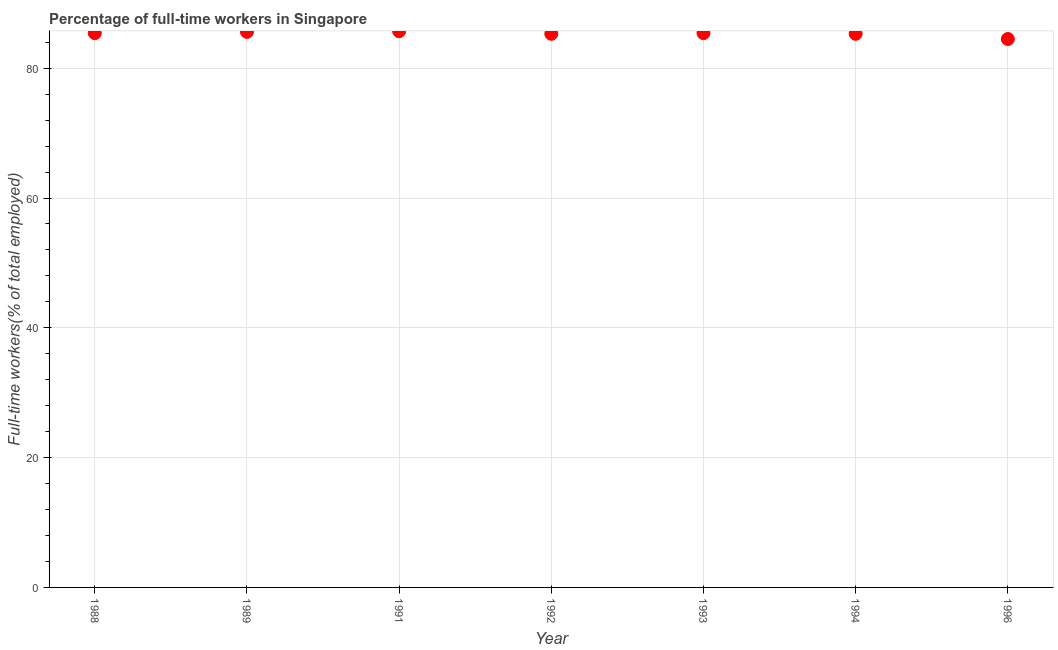What is the percentage of full-time workers in 1988?
Your response must be concise. 85.4. Across all years, what is the maximum percentage of full-time workers?
Make the answer very short. 85.7. Across all years, what is the minimum percentage of full-time workers?
Ensure brevity in your answer.  84.5. In which year was the percentage of full-time workers minimum?
Offer a terse response. 1996. What is the sum of the percentage of full-time workers?
Your answer should be very brief. 597.2. What is the difference between the percentage of full-time workers in 1994 and 1996?
Offer a very short reply. 0.8. What is the average percentage of full-time workers per year?
Your answer should be very brief. 85.31. What is the median percentage of full-time workers?
Your answer should be compact. 85.4. In how many years, is the percentage of full-time workers greater than 40 %?
Provide a short and direct response. 7. What is the ratio of the percentage of full-time workers in 1989 to that in 1992?
Provide a short and direct response. 1. Is the difference between the percentage of full-time workers in 1993 and 1994 greater than the difference between any two years?
Provide a succinct answer. No. What is the difference between the highest and the second highest percentage of full-time workers?
Provide a succinct answer. 0.1. What is the difference between the highest and the lowest percentage of full-time workers?
Provide a short and direct response. 1.2. Does the percentage of full-time workers monotonically increase over the years?
Provide a succinct answer. No. How many dotlines are there?
Your response must be concise. 1. How many years are there in the graph?
Keep it short and to the point. 7. What is the difference between two consecutive major ticks on the Y-axis?
Ensure brevity in your answer.  20. Does the graph contain grids?
Keep it short and to the point. Yes. What is the title of the graph?
Offer a very short reply. Percentage of full-time workers in Singapore. What is the label or title of the X-axis?
Your answer should be very brief. Year. What is the label or title of the Y-axis?
Make the answer very short. Full-time workers(% of total employed). What is the Full-time workers(% of total employed) in 1988?
Your answer should be compact. 85.4. What is the Full-time workers(% of total employed) in 1989?
Your answer should be compact. 85.6. What is the Full-time workers(% of total employed) in 1991?
Your response must be concise. 85.7. What is the Full-time workers(% of total employed) in 1992?
Give a very brief answer. 85.3. What is the Full-time workers(% of total employed) in 1993?
Give a very brief answer. 85.4. What is the Full-time workers(% of total employed) in 1994?
Ensure brevity in your answer.  85.3. What is the Full-time workers(% of total employed) in 1996?
Ensure brevity in your answer.  84.5. What is the difference between the Full-time workers(% of total employed) in 1988 and 1989?
Your answer should be very brief. -0.2. What is the difference between the Full-time workers(% of total employed) in 1988 and 1991?
Provide a succinct answer. -0.3. What is the difference between the Full-time workers(% of total employed) in 1988 and 1992?
Offer a very short reply. 0.1. What is the difference between the Full-time workers(% of total employed) in 1988 and 1993?
Your response must be concise. 0. What is the difference between the Full-time workers(% of total employed) in 1988 and 1994?
Your answer should be very brief. 0.1. What is the difference between the Full-time workers(% of total employed) in 1989 and 1991?
Make the answer very short. -0.1. What is the difference between the Full-time workers(% of total employed) in 1989 and 1993?
Give a very brief answer. 0.2. What is the difference between the Full-time workers(% of total employed) in 1989 and 1996?
Offer a terse response. 1.1. What is the difference between the Full-time workers(% of total employed) in 1991 and 1992?
Ensure brevity in your answer.  0.4. What is the difference between the Full-time workers(% of total employed) in 1991 and 1993?
Offer a terse response. 0.3. What is the difference between the Full-time workers(% of total employed) in 1991 and 1994?
Make the answer very short. 0.4. What is the difference between the Full-time workers(% of total employed) in 1991 and 1996?
Offer a very short reply. 1.2. What is the difference between the Full-time workers(% of total employed) in 1993 and 1994?
Offer a very short reply. 0.1. What is the difference between the Full-time workers(% of total employed) in 1993 and 1996?
Your answer should be very brief. 0.9. What is the ratio of the Full-time workers(% of total employed) in 1988 to that in 1989?
Provide a short and direct response. 1. What is the ratio of the Full-time workers(% of total employed) in 1988 to that in 1992?
Keep it short and to the point. 1. What is the ratio of the Full-time workers(% of total employed) in 1988 to that in 1994?
Your response must be concise. 1. What is the ratio of the Full-time workers(% of total employed) in 1989 to that in 1991?
Keep it short and to the point. 1. What is the ratio of the Full-time workers(% of total employed) in 1991 to that in 1993?
Offer a terse response. 1. What is the ratio of the Full-time workers(% of total employed) in 1991 to that in 1994?
Provide a succinct answer. 1. What is the ratio of the Full-time workers(% of total employed) in 1992 to that in 1996?
Your answer should be very brief. 1.01. What is the ratio of the Full-time workers(% of total employed) in 1993 to that in 1996?
Offer a very short reply. 1.01. What is the ratio of the Full-time workers(% of total employed) in 1994 to that in 1996?
Offer a terse response. 1.01. 